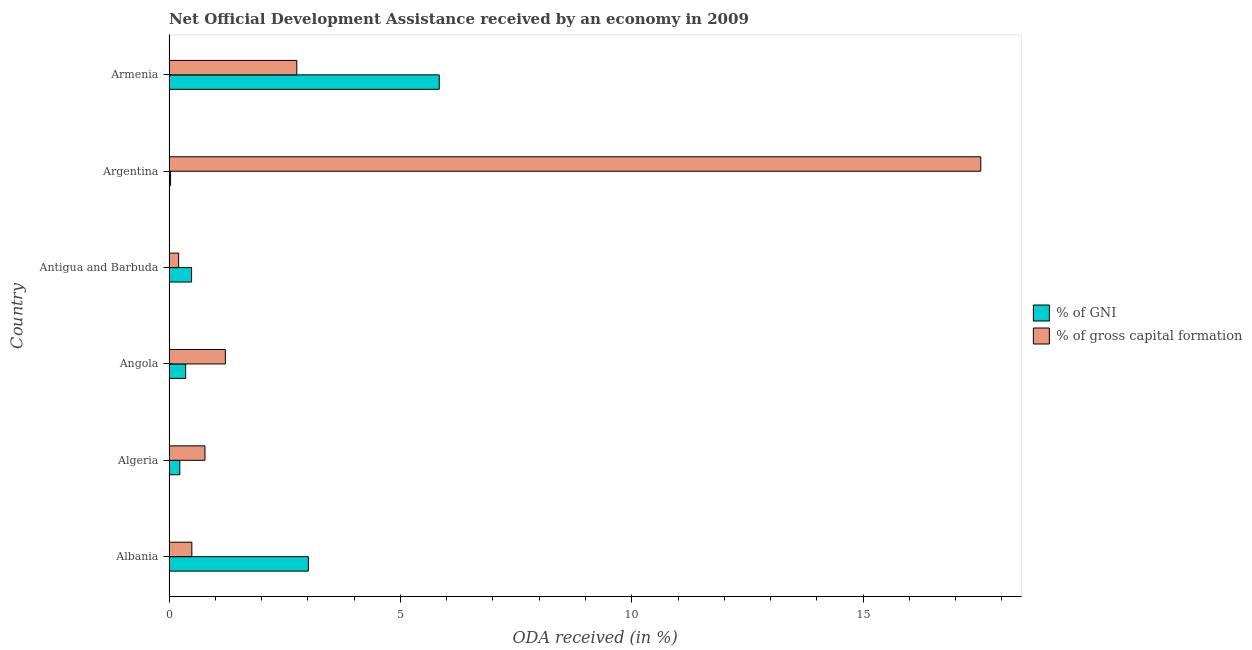How many different coloured bars are there?
Your answer should be very brief. 2. How many groups of bars are there?
Provide a succinct answer. 6. What is the label of the 5th group of bars from the top?
Your answer should be very brief. Algeria. In how many cases, is the number of bars for a given country not equal to the number of legend labels?
Make the answer very short. 0. What is the oda received as percentage of gross capital formation in Angola?
Provide a succinct answer. 1.22. Across all countries, what is the maximum oda received as percentage of gni?
Provide a succinct answer. 5.84. Across all countries, what is the minimum oda received as percentage of gross capital formation?
Give a very brief answer. 0.21. In which country was the oda received as percentage of gni maximum?
Make the answer very short. Armenia. In which country was the oda received as percentage of gross capital formation minimum?
Your response must be concise. Antigua and Barbuda. What is the total oda received as percentage of gross capital formation in the graph?
Offer a terse response. 23. What is the difference between the oda received as percentage of gni in Albania and that in Argentina?
Your answer should be compact. 2.98. What is the difference between the oda received as percentage of gni in Albania and the oda received as percentage of gross capital formation in Algeria?
Your answer should be very brief. 2.23. What is the average oda received as percentage of gross capital formation per country?
Keep it short and to the point. 3.83. What is the difference between the oda received as percentage of gross capital formation and oda received as percentage of gni in Algeria?
Your answer should be very brief. 0.54. What is the ratio of the oda received as percentage of gross capital formation in Argentina to that in Armenia?
Your answer should be compact. 6.35. Is the oda received as percentage of gni in Albania less than that in Algeria?
Give a very brief answer. No. What is the difference between the highest and the second highest oda received as percentage of gni?
Your answer should be compact. 2.83. What is the difference between the highest and the lowest oda received as percentage of gni?
Provide a short and direct response. 5.81. What does the 2nd bar from the top in Armenia represents?
Give a very brief answer. % of GNI. What does the 2nd bar from the bottom in Armenia represents?
Make the answer very short. % of gross capital formation. How many bars are there?
Provide a short and direct response. 12. Are all the bars in the graph horizontal?
Offer a terse response. Yes. How many countries are there in the graph?
Your response must be concise. 6. Where does the legend appear in the graph?
Your answer should be very brief. Center right. How are the legend labels stacked?
Offer a terse response. Vertical. What is the title of the graph?
Provide a short and direct response. Net Official Development Assistance received by an economy in 2009. What is the label or title of the X-axis?
Give a very brief answer. ODA received (in %). What is the ODA received (in %) in % of GNI in Albania?
Keep it short and to the point. 3.01. What is the ODA received (in %) of % of gross capital formation in Albania?
Your answer should be compact. 0.49. What is the ODA received (in %) of % of GNI in Algeria?
Your answer should be compact. 0.23. What is the ODA received (in %) in % of gross capital formation in Algeria?
Keep it short and to the point. 0.78. What is the ODA received (in %) in % of GNI in Angola?
Your response must be concise. 0.36. What is the ODA received (in %) of % of gross capital formation in Angola?
Your answer should be very brief. 1.22. What is the ODA received (in %) in % of GNI in Antigua and Barbuda?
Make the answer very short. 0.49. What is the ODA received (in %) of % of gross capital formation in Antigua and Barbuda?
Keep it short and to the point. 0.21. What is the ODA received (in %) of % of GNI in Argentina?
Provide a short and direct response. 0.03. What is the ODA received (in %) in % of gross capital formation in Argentina?
Offer a very short reply. 17.54. What is the ODA received (in %) in % of GNI in Armenia?
Ensure brevity in your answer.  5.84. What is the ODA received (in %) of % of gross capital formation in Armenia?
Offer a very short reply. 2.76. Across all countries, what is the maximum ODA received (in %) in % of GNI?
Offer a very short reply. 5.84. Across all countries, what is the maximum ODA received (in %) of % of gross capital formation?
Make the answer very short. 17.54. Across all countries, what is the minimum ODA received (in %) of % of GNI?
Your answer should be very brief. 0.03. Across all countries, what is the minimum ODA received (in %) in % of gross capital formation?
Your answer should be compact. 0.21. What is the total ODA received (in %) in % of GNI in the graph?
Keep it short and to the point. 9.97. What is the total ODA received (in %) of % of gross capital formation in the graph?
Your answer should be very brief. 23. What is the difference between the ODA received (in %) in % of GNI in Albania and that in Algeria?
Ensure brevity in your answer.  2.78. What is the difference between the ODA received (in %) of % of gross capital formation in Albania and that in Algeria?
Give a very brief answer. -0.28. What is the difference between the ODA received (in %) in % of GNI in Albania and that in Angola?
Keep it short and to the point. 2.65. What is the difference between the ODA received (in %) of % of gross capital formation in Albania and that in Angola?
Make the answer very short. -0.72. What is the difference between the ODA received (in %) of % of GNI in Albania and that in Antigua and Barbuda?
Ensure brevity in your answer.  2.52. What is the difference between the ODA received (in %) of % of gross capital formation in Albania and that in Antigua and Barbuda?
Keep it short and to the point. 0.29. What is the difference between the ODA received (in %) in % of GNI in Albania and that in Argentina?
Offer a very short reply. 2.98. What is the difference between the ODA received (in %) in % of gross capital formation in Albania and that in Argentina?
Your response must be concise. -17.05. What is the difference between the ODA received (in %) of % of GNI in Albania and that in Armenia?
Ensure brevity in your answer.  -2.83. What is the difference between the ODA received (in %) in % of gross capital formation in Albania and that in Armenia?
Ensure brevity in your answer.  -2.27. What is the difference between the ODA received (in %) of % of GNI in Algeria and that in Angola?
Provide a succinct answer. -0.13. What is the difference between the ODA received (in %) in % of gross capital formation in Algeria and that in Angola?
Keep it short and to the point. -0.44. What is the difference between the ODA received (in %) of % of GNI in Algeria and that in Antigua and Barbuda?
Give a very brief answer. -0.25. What is the difference between the ODA received (in %) of % of gross capital formation in Algeria and that in Antigua and Barbuda?
Ensure brevity in your answer.  0.57. What is the difference between the ODA received (in %) of % of GNI in Algeria and that in Argentina?
Your answer should be very brief. 0.2. What is the difference between the ODA received (in %) in % of gross capital formation in Algeria and that in Argentina?
Provide a succinct answer. -16.77. What is the difference between the ODA received (in %) in % of GNI in Algeria and that in Armenia?
Ensure brevity in your answer.  -5.61. What is the difference between the ODA received (in %) of % of gross capital formation in Algeria and that in Armenia?
Make the answer very short. -1.98. What is the difference between the ODA received (in %) of % of GNI in Angola and that in Antigua and Barbuda?
Offer a terse response. -0.13. What is the difference between the ODA received (in %) of % of gross capital formation in Angola and that in Antigua and Barbuda?
Ensure brevity in your answer.  1.01. What is the difference between the ODA received (in %) of % of GNI in Angola and that in Argentina?
Your answer should be very brief. 0.33. What is the difference between the ODA received (in %) in % of gross capital formation in Angola and that in Argentina?
Offer a very short reply. -16.32. What is the difference between the ODA received (in %) in % of GNI in Angola and that in Armenia?
Give a very brief answer. -5.48. What is the difference between the ODA received (in %) in % of gross capital formation in Angola and that in Armenia?
Provide a short and direct response. -1.54. What is the difference between the ODA received (in %) of % of GNI in Antigua and Barbuda and that in Argentina?
Ensure brevity in your answer.  0.45. What is the difference between the ODA received (in %) in % of gross capital formation in Antigua and Barbuda and that in Argentina?
Make the answer very short. -17.33. What is the difference between the ODA received (in %) of % of GNI in Antigua and Barbuda and that in Armenia?
Give a very brief answer. -5.35. What is the difference between the ODA received (in %) in % of gross capital formation in Antigua and Barbuda and that in Armenia?
Your answer should be very brief. -2.55. What is the difference between the ODA received (in %) of % of GNI in Argentina and that in Armenia?
Ensure brevity in your answer.  -5.81. What is the difference between the ODA received (in %) of % of gross capital formation in Argentina and that in Armenia?
Your answer should be very brief. 14.78. What is the difference between the ODA received (in %) in % of GNI in Albania and the ODA received (in %) in % of gross capital formation in Algeria?
Your answer should be very brief. 2.23. What is the difference between the ODA received (in %) in % of GNI in Albania and the ODA received (in %) in % of gross capital formation in Angola?
Your answer should be very brief. 1.79. What is the difference between the ODA received (in %) in % of GNI in Albania and the ODA received (in %) in % of gross capital formation in Antigua and Barbuda?
Your answer should be very brief. 2.8. What is the difference between the ODA received (in %) in % of GNI in Albania and the ODA received (in %) in % of gross capital formation in Argentina?
Provide a succinct answer. -14.53. What is the difference between the ODA received (in %) of % of GNI in Albania and the ODA received (in %) of % of gross capital formation in Armenia?
Your response must be concise. 0.25. What is the difference between the ODA received (in %) in % of GNI in Algeria and the ODA received (in %) in % of gross capital formation in Angola?
Your answer should be very brief. -0.98. What is the difference between the ODA received (in %) in % of GNI in Algeria and the ODA received (in %) in % of gross capital formation in Antigua and Barbuda?
Ensure brevity in your answer.  0.03. What is the difference between the ODA received (in %) in % of GNI in Algeria and the ODA received (in %) in % of gross capital formation in Argentina?
Offer a terse response. -17.31. What is the difference between the ODA received (in %) in % of GNI in Algeria and the ODA received (in %) in % of gross capital formation in Armenia?
Offer a terse response. -2.53. What is the difference between the ODA received (in %) in % of GNI in Angola and the ODA received (in %) in % of gross capital formation in Antigua and Barbuda?
Offer a terse response. 0.15. What is the difference between the ODA received (in %) in % of GNI in Angola and the ODA received (in %) in % of gross capital formation in Argentina?
Your answer should be very brief. -17.18. What is the difference between the ODA received (in %) in % of GNI in Angola and the ODA received (in %) in % of gross capital formation in Armenia?
Offer a very short reply. -2.4. What is the difference between the ODA received (in %) of % of GNI in Antigua and Barbuda and the ODA received (in %) of % of gross capital formation in Argentina?
Your answer should be compact. -17.05. What is the difference between the ODA received (in %) in % of GNI in Antigua and Barbuda and the ODA received (in %) in % of gross capital formation in Armenia?
Your answer should be compact. -2.27. What is the difference between the ODA received (in %) in % of GNI in Argentina and the ODA received (in %) in % of gross capital formation in Armenia?
Ensure brevity in your answer.  -2.73. What is the average ODA received (in %) of % of GNI per country?
Offer a very short reply. 1.66. What is the average ODA received (in %) of % of gross capital formation per country?
Keep it short and to the point. 3.83. What is the difference between the ODA received (in %) in % of GNI and ODA received (in %) in % of gross capital formation in Albania?
Provide a short and direct response. 2.52. What is the difference between the ODA received (in %) in % of GNI and ODA received (in %) in % of gross capital formation in Algeria?
Your answer should be very brief. -0.54. What is the difference between the ODA received (in %) in % of GNI and ODA received (in %) in % of gross capital formation in Angola?
Offer a terse response. -0.86. What is the difference between the ODA received (in %) in % of GNI and ODA received (in %) in % of gross capital formation in Antigua and Barbuda?
Provide a short and direct response. 0.28. What is the difference between the ODA received (in %) of % of GNI and ODA received (in %) of % of gross capital formation in Argentina?
Offer a very short reply. -17.51. What is the difference between the ODA received (in %) in % of GNI and ODA received (in %) in % of gross capital formation in Armenia?
Offer a very short reply. 3.08. What is the ratio of the ODA received (in %) in % of GNI in Albania to that in Algeria?
Provide a short and direct response. 12.9. What is the ratio of the ODA received (in %) of % of gross capital formation in Albania to that in Algeria?
Provide a short and direct response. 0.64. What is the ratio of the ODA received (in %) of % of GNI in Albania to that in Angola?
Ensure brevity in your answer.  8.37. What is the ratio of the ODA received (in %) of % of gross capital formation in Albania to that in Angola?
Ensure brevity in your answer.  0.41. What is the ratio of the ODA received (in %) of % of GNI in Albania to that in Antigua and Barbuda?
Ensure brevity in your answer.  6.17. What is the ratio of the ODA received (in %) of % of gross capital formation in Albania to that in Antigua and Barbuda?
Ensure brevity in your answer.  2.37. What is the ratio of the ODA received (in %) of % of GNI in Albania to that in Argentina?
Keep it short and to the point. 87.39. What is the ratio of the ODA received (in %) of % of gross capital formation in Albania to that in Argentina?
Your response must be concise. 0.03. What is the ratio of the ODA received (in %) in % of GNI in Albania to that in Armenia?
Keep it short and to the point. 0.52. What is the ratio of the ODA received (in %) in % of gross capital formation in Albania to that in Armenia?
Keep it short and to the point. 0.18. What is the ratio of the ODA received (in %) of % of GNI in Algeria to that in Angola?
Your answer should be compact. 0.65. What is the ratio of the ODA received (in %) in % of gross capital formation in Algeria to that in Angola?
Your response must be concise. 0.64. What is the ratio of the ODA received (in %) in % of GNI in Algeria to that in Antigua and Barbuda?
Make the answer very short. 0.48. What is the ratio of the ODA received (in %) in % of gross capital formation in Algeria to that in Antigua and Barbuda?
Ensure brevity in your answer.  3.73. What is the ratio of the ODA received (in %) of % of GNI in Algeria to that in Argentina?
Keep it short and to the point. 6.77. What is the ratio of the ODA received (in %) of % of gross capital formation in Algeria to that in Argentina?
Provide a short and direct response. 0.04. What is the ratio of the ODA received (in %) of % of GNI in Algeria to that in Armenia?
Make the answer very short. 0.04. What is the ratio of the ODA received (in %) of % of gross capital formation in Algeria to that in Armenia?
Make the answer very short. 0.28. What is the ratio of the ODA received (in %) of % of GNI in Angola to that in Antigua and Barbuda?
Make the answer very short. 0.74. What is the ratio of the ODA received (in %) in % of gross capital formation in Angola to that in Antigua and Barbuda?
Your response must be concise. 5.85. What is the ratio of the ODA received (in %) of % of GNI in Angola to that in Argentina?
Offer a very short reply. 10.44. What is the ratio of the ODA received (in %) of % of gross capital formation in Angola to that in Argentina?
Your answer should be compact. 0.07. What is the ratio of the ODA received (in %) of % of GNI in Angola to that in Armenia?
Ensure brevity in your answer.  0.06. What is the ratio of the ODA received (in %) in % of gross capital formation in Angola to that in Armenia?
Your response must be concise. 0.44. What is the ratio of the ODA received (in %) of % of GNI in Antigua and Barbuda to that in Argentina?
Keep it short and to the point. 14.16. What is the ratio of the ODA received (in %) in % of gross capital formation in Antigua and Barbuda to that in Argentina?
Make the answer very short. 0.01. What is the ratio of the ODA received (in %) in % of GNI in Antigua and Barbuda to that in Armenia?
Keep it short and to the point. 0.08. What is the ratio of the ODA received (in %) of % of gross capital formation in Antigua and Barbuda to that in Armenia?
Offer a very short reply. 0.08. What is the ratio of the ODA received (in %) in % of GNI in Argentina to that in Armenia?
Your answer should be compact. 0.01. What is the ratio of the ODA received (in %) in % of gross capital formation in Argentina to that in Armenia?
Provide a succinct answer. 6.35. What is the difference between the highest and the second highest ODA received (in %) in % of GNI?
Your response must be concise. 2.83. What is the difference between the highest and the second highest ODA received (in %) in % of gross capital formation?
Provide a short and direct response. 14.78. What is the difference between the highest and the lowest ODA received (in %) of % of GNI?
Keep it short and to the point. 5.81. What is the difference between the highest and the lowest ODA received (in %) of % of gross capital formation?
Your answer should be very brief. 17.33. 